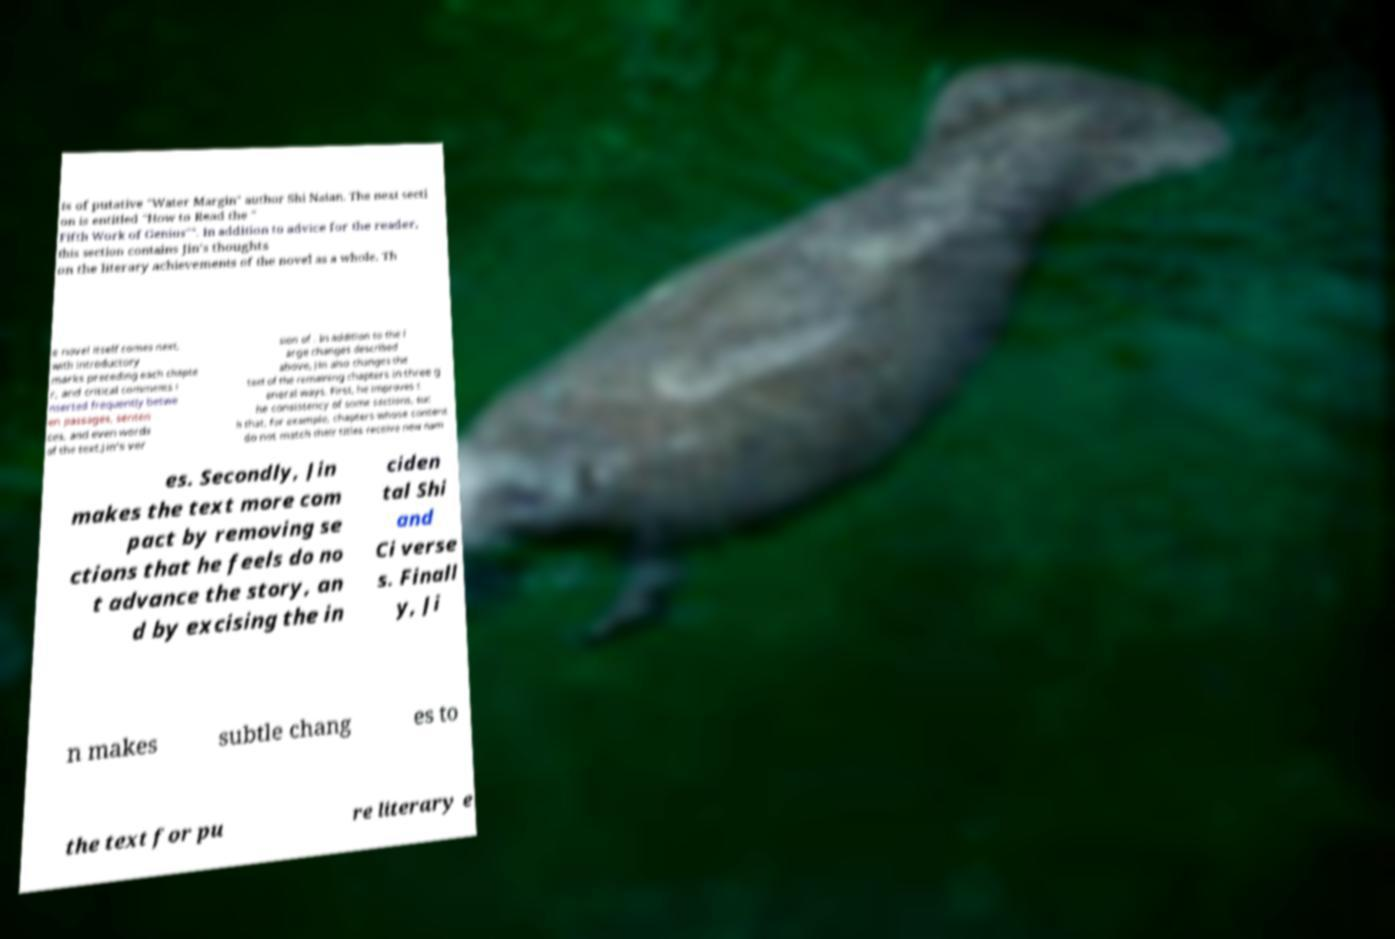Please read and relay the text visible in this image. What does it say? ts of putative "Water Margin" author Shi Naian. The next secti on is entitled "How to Read the " Fifth Work of Genius"". In addition to advice for the reader, this section contains Jin's thoughts on the literary achievements of the novel as a whole. Th e novel itself comes next, with introductory marks preceding each chapte r, and critical comments i nserted frequently betwe en passages, senten ces, and even words of the text.Jin's ver sion of . In addition to the l arge changes described above, Jin also changes the text of the remaining chapters in three g eneral ways. First, he improves t he consistency of some sections, suc h that, for example, chapters whose content do not match their titles receive new nam es. Secondly, Jin makes the text more com pact by removing se ctions that he feels do no t advance the story, an d by excising the in ciden tal Shi and Ci verse s. Finall y, Ji n makes subtle chang es to the text for pu re literary e 